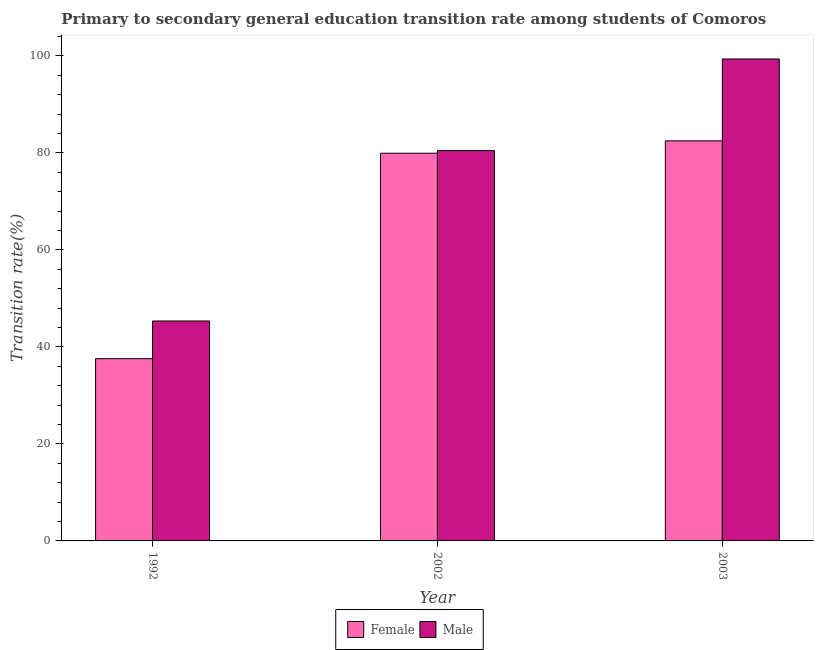How many different coloured bars are there?
Give a very brief answer. 2. How many bars are there on the 3rd tick from the left?
Make the answer very short. 2. How many bars are there on the 1st tick from the right?
Offer a terse response. 2. What is the transition rate among male students in 2003?
Provide a succinct answer. 99.36. Across all years, what is the maximum transition rate among male students?
Your answer should be compact. 99.36. Across all years, what is the minimum transition rate among female students?
Provide a succinct answer. 37.57. In which year was the transition rate among female students maximum?
Provide a succinct answer. 2003. What is the total transition rate among male students in the graph?
Ensure brevity in your answer.  225.18. What is the difference between the transition rate among male students in 2002 and that in 2003?
Make the answer very short. -18.89. What is the difference between the transition rate among female students in 2003 and the transition rate among male students in 2002?
Provide a succinct answer. 2.54. What is the average transition rate among female students per year?
Your response must be concise. 66.66. In how many years, is the transition rate among female students greater than 100 %?
Provide a succinct answer. 0. What is the ratio of the transition rate among female students in 2002 to that in 2003?
Offer a terse response. 0.97. Is the transition rate among male students in 2002 less than that in 2003?
Make the answer very short. Yes. What is the difference between the highest and the second highest transition rate among female students?
Keep it short and to the point. 2.54. What is the difference between the highest and the lowest transition rate among male students?
Your answer should be very brief. 54.02. What does the 1st bar from the right in 1992 represents?
Offer a terse response. Male. How many bars are there?
Your response must be concise. 6. What is the difference between two consecutive major ticks on the Y-axis?
Keep it short and to the point. 20. Are the values on the major ticks of Y-axis written in scientific E-notation?
Ensure brevity in your answer.  No. Does the graph contain any zero values?
Keep it short and to the point. No. Where does the legend appear in the graph?
Provide a succinct answer. Bottom center. How many legend labels are there?
Ensure brevity in your answer.  2. What is the title of the graph?
Make the answer very short. Primary to secondary general education transition rate among students of Comoros. What is the label or title of the Y-axis?
Offer a terse response. Transition rate(%). What is the Transition rate(%) in Female in 1992?
Your response must be concise. 37.57. What is the Transition rate(%) in Male in 1992?
Keep it short and to the point. 45.34. What is the Transition rate(%) in Female in 2002?
Offer a very short reply. 79.93. What is the Transition rate(%) in Male in 2002?
Keep it short and to the point. 80.47. What is the Transition rate(%) in Female in 2003?
Offer a very short reply. 82.48. What is the Transition rate(%) of Male in 2003?
Your response must be concise. 99.36. Across all years, what is the maximum Transition rate(%) in Female?
Give a very brief answer. 82.48. Across all years, what is the maximum Transition rate(%) in Male?
Give a very brief answer. 99.36. Across all years, what is the minimum Transition rate(%) in Female?
Give a very brief answer. 37.57. Across all years, what is the minimum Transition rate(%) of Male?
Keep it short and to the point. 45.34. What is the total Transition rate(%) of Female in the graph?
Provide a succinct answer. 199.99. What is the total Transition rate(%) of Male in the graph?
Provide a succinct answer. 225.18. What is the difference between the Transition rate(%) of Female in 1992 and that in 2002?
Provide a succinct answer. -42.36. What is the difference between the Transition rate(%) of Male in 1992 and that in 2002?
Give a very brief answer. -35.13. What is the difference between the Transition rate(%) of Female in 1992 and that in 2003?
Your answer should be very brief. -44.9. What is the difference between the Transition rate(%) in Male in 1992 and that in 2003?
Your response must be concise. -54.02. What is the difference between the Transition rate(%) in Female in 2002 and that in 2003?
Keep it short and to the point. -2.54. What is the difference between the Transition rate(%) of Male in 2002 and that in 2003?
Your response must be concise. -18.89. What is the difference between the Transition rate(%) in Female in 1992 and the Transition rate(%) in Male in 2002?
Offer a very short reply. -42.9. What is the difference between the Transition rate(%) in Female in 1992 and the Transition rate(%) in Male in 2003?
Your response must be concise. -61.79. What is the difference between the Transition rate(%) in Female in 2002 and the Transition rate(%) in Male in 2003?
Give a very brief answer. -19.43. What is the average Transition rate(%) of Female per year?
Give a very brief answer. 66.66. What is the average Transition rate(%) of Male per year?
Keep it short and to the point. 75.06. In the year 1992, what is the difference between the Transition rate(%) of Female and Transition rate(%) of Male?
Your response must be concise. -7.77. In the year 2002, what is the difference between the Transition rate(%) in Female and Transition rate(%) in Male?
Your response must be concise. -0.54. In the year 2003, what is the difference between the Transition rate(%) in Female and Transition rate(%) in Male?
Your response must be concise. -16.88. What is the ratio of the Transition rate(%) in Female in 1992 to that in 2002?
Keep it short and to the point. 0.47. What is the ratio of the Transition rate(%) in Male in 1992 to that in 2002?
Keep it short and to the point. 0.56. What is the ratio of the Transition rate(%) of Female in 1992 to that in 2003?
Provide a succinct answer. 0.46. What is the ratio of the Transition rate(%) of Male in 1992 to that in 2003?
Provide a short and direct response. 0.46. What is the ratio of the Transition rate(%) in Female in 2002 to that in 2003?
Give a very brief answer. 0.97. What is the ratio of the Transition rate(%) of Male in 2002 to that in 2003?
Your answer should be compact. 0.81. What is the difference between the highest and the second highest Transition rate(%) of Female?
Give a very brief answer. 2.54. What is the difference between the highest and the second highest Transition rate(%) in Male?
Your answer should be compact. 18.89. What is the difference between the highest and the lowest Transition rate(%) of Female?
Offer a very short reply. 44.9. What is the difference between the highest and the lowest Transition rate(%) in Male?
Offer a terse response. 54.02. 